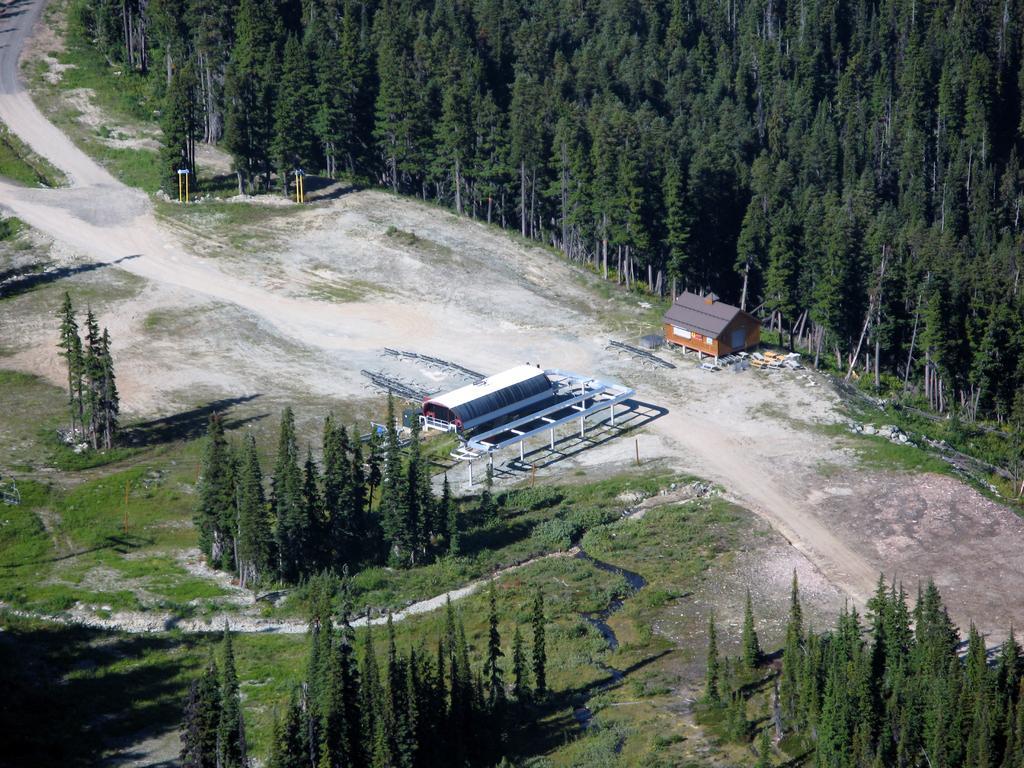Can you describe this image briefly? In this image I can see the ground, some grass, few buildings, few trees which are green in color, few poles and the road. 